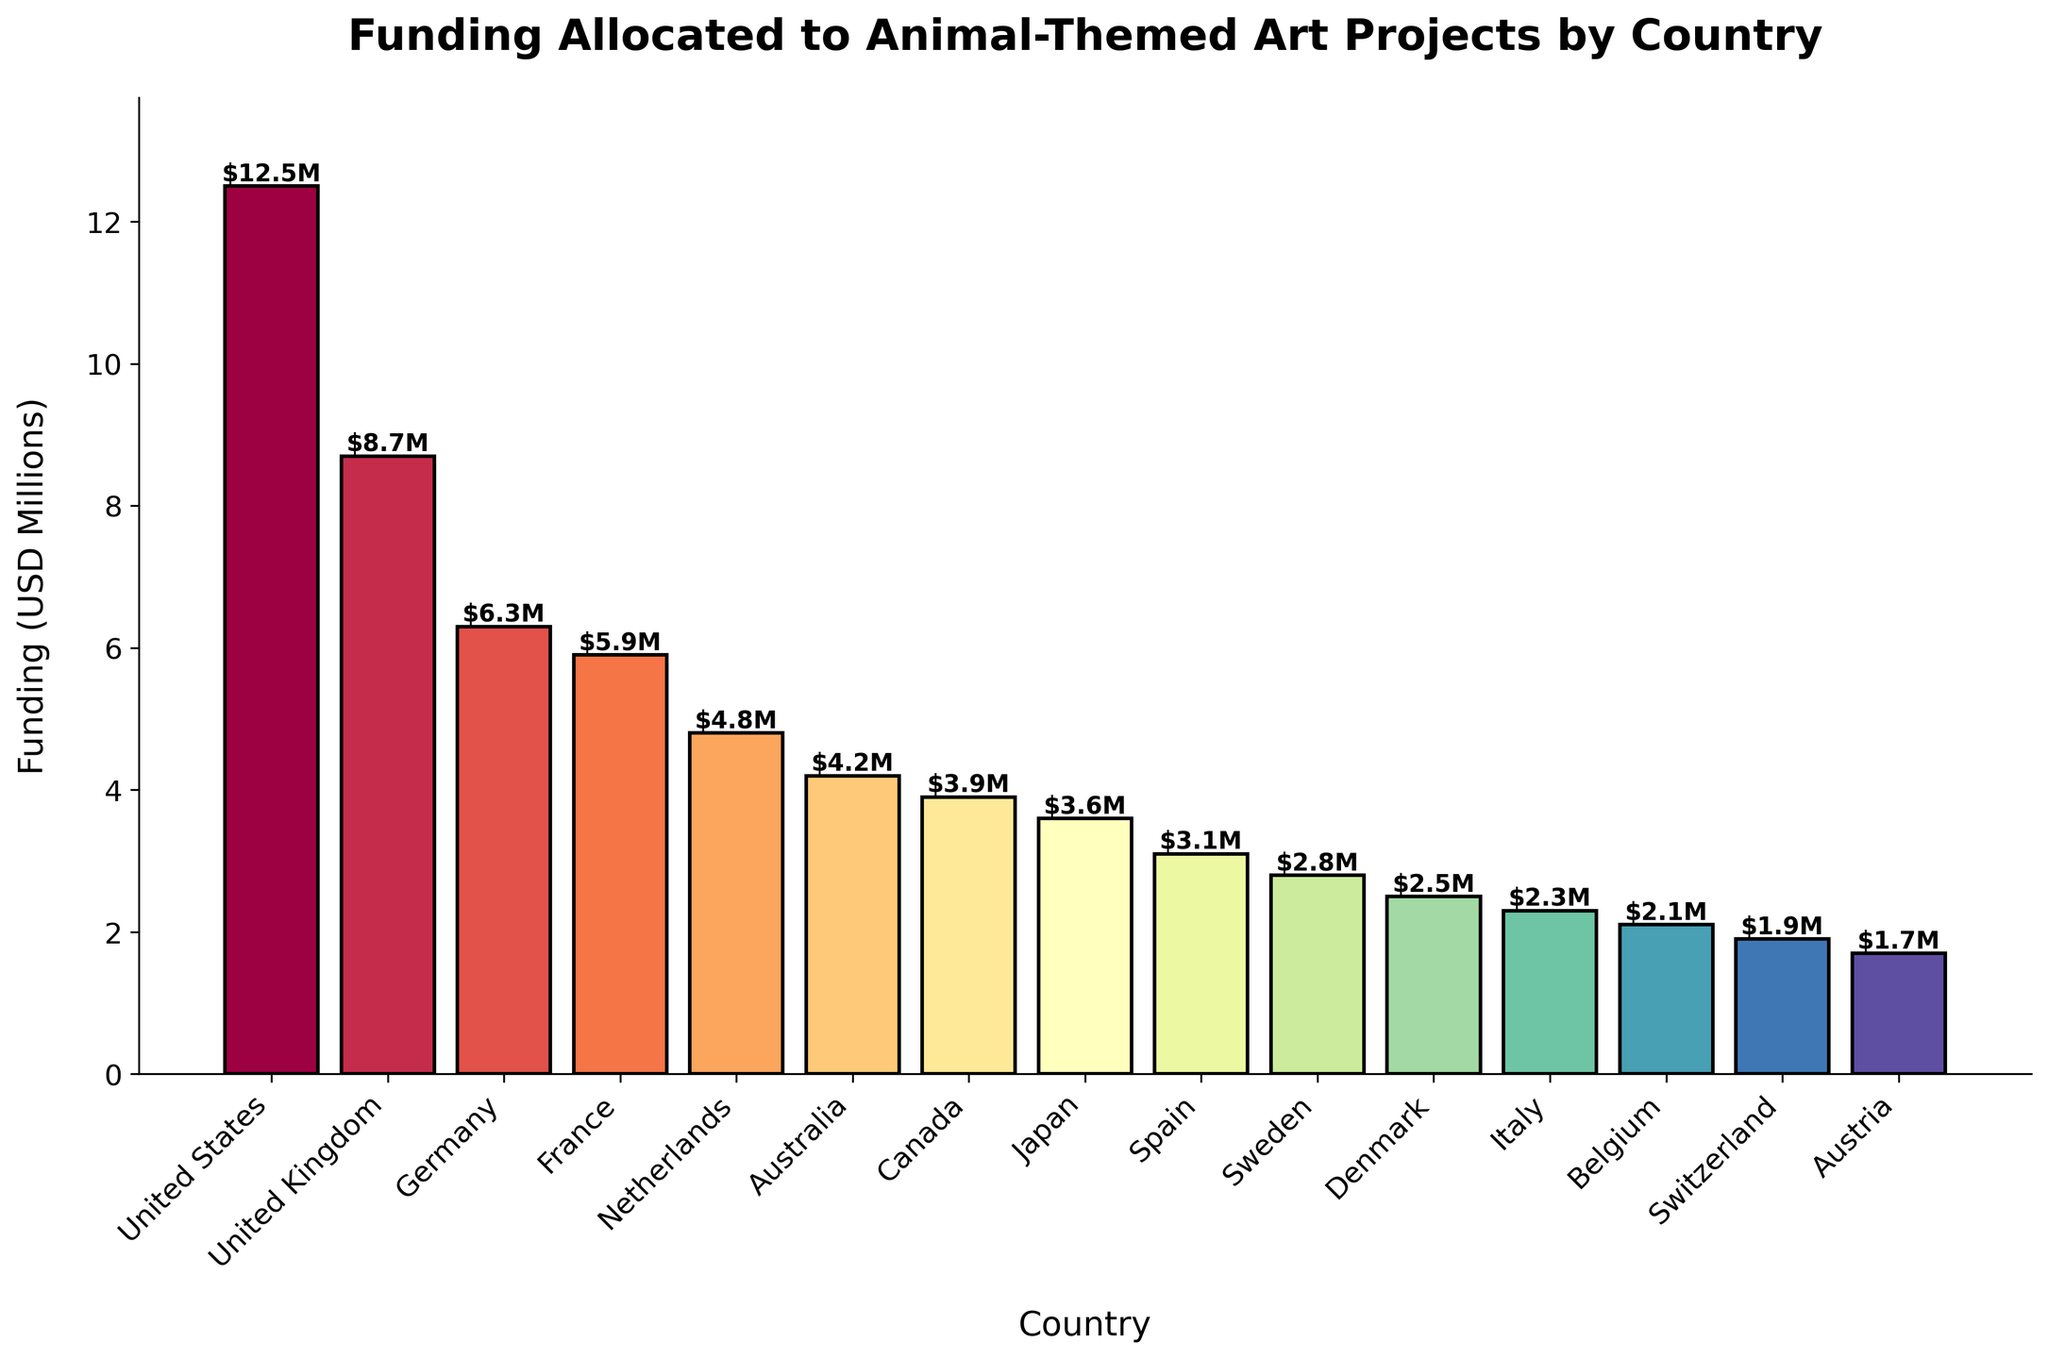Which country has allocated the most funding to animal-themed art projects? By observing the height of the bars in the chart, it's clear that the bar for the United States is the tallest, indicating the highest funding.
Answer: United States Which country has allocated the least funding to animal-themed art projects? When looking at the heights of the bars, it can be seen that the bar for Austria is the shortest, indicating the lowest funding.
Answer: Austria How much more funding has the United States allocated compared to France? The funding for the United States is 12.5 million USD, and for France, it is 5.9 million USD. Subtracting these values gives: 12.5 - 5.9 = 6.6 million USD.
Answer: 6.6 million USD Which countries have allocated more than 5 million USD in funding? Observing the bars, the countries with funding bars exceeding the 5 million USD mark are the United States, United Kingdom, Germany, and France.
Answer: United States, United Kingdom, Germany, and France What is the total funding allocated by Germany, France, and the Netherlands? Summing the funding amounts for these countries: Germany (6.3 million) + France (5.9 million) + Netherlands (4.8 million) = 17 million USD.
Answer: 17 million USD Comparing Australia and Japan, which country has allocated more funding and by how much? Australia allocated 4.2 million USD, whereas Japan allocated 3.6 million USD. The difference is 4.2 - 3.6 = 0.6 million USD.
Answer: Australia by 0.6 million USD How many countries have allocated between 2 million and 5 million USD in funding? By observing the chart, the countries that fall within this range are Netherlands, Australia, Canada, Japan, Spain, Sweden, Denmark, Italy, Belgium, and Switzerland, totaling 10 countries.
Answer: 10 countries What is the average funding allocated by the top three countries? The top three countries are the United States (12.5 million), United Kingdom (8.7 million), and Germany (6.3 million). The average is calculated as (12.5 + 8.7 + 6.3) / 3 = 9.17 million USD.
Answer: 9.17 million USD Which countries' funding amounts fall below 3 million USD? Observing the chart, Spain, Sweden, Denmark, Italy, Belgium, Switzerland, and Austria fall below the 3 million USD funding mark.
Answer: Spain, Sweden, Denmark, Italy, Belgium, Switzerland, and Austria What is the combined funding for Canada and Japan? Adding the funding amounts for Canada (3.9 million) and Japan (3.6 million) gives: 3.9 + 3.6 = 7.5 million USD.
Answer: 7.5 million USD 